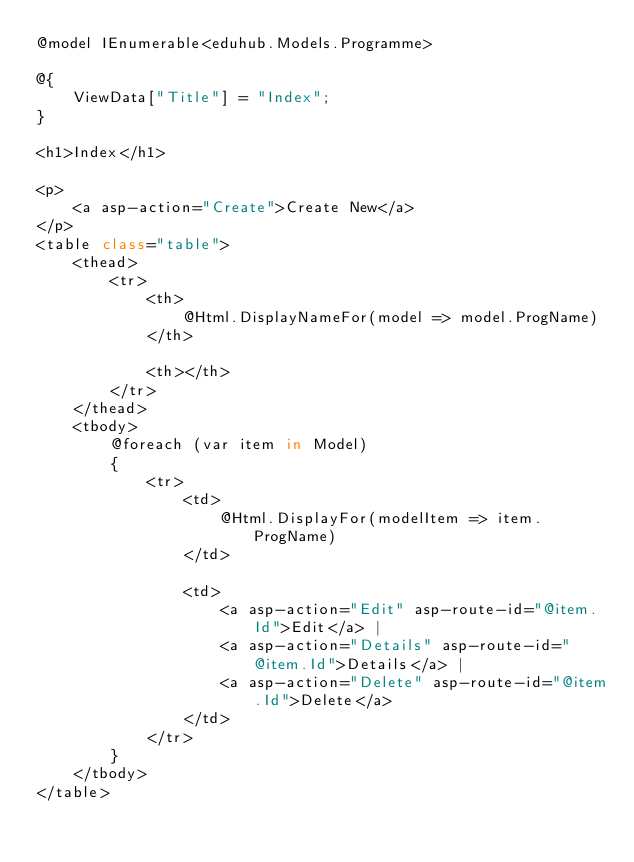<code> <loc_0><loc_0><loc_500><loc_500><_C#_>@model IEnumerable<eduhub.Models.Programme>

@{
    ViewData["Title"] = "Index";
}

<h1>Index</h1>

<p>
    <a asp-action="Create">Create New</a>
</p>
<table class="table">
    <thead>
        <tr>
            <th>
                @Html.DisplayNameFor(model => model.ProgName)
            </th>

            <th></th>
        </tr>
    </thead>
    <tbody>
        @foreach (var item in Model)
        {
            <tr>
                <td>
                    @Html.DisplayFor(modelItem => item.ProgName)
                </td>
              
                <td>
                    <a asp-action="Edit" asp-route-id="@item.Id">Edit</a> |
                    <a asp-action="Details" asp-route-id="@item.Id">Details</a> |
                    <a asp-action="Delete" asp-route-id="@item.Id">Delete</a>
                </td>
            </tr>
        }
    </tbody>
</table>
</code> 